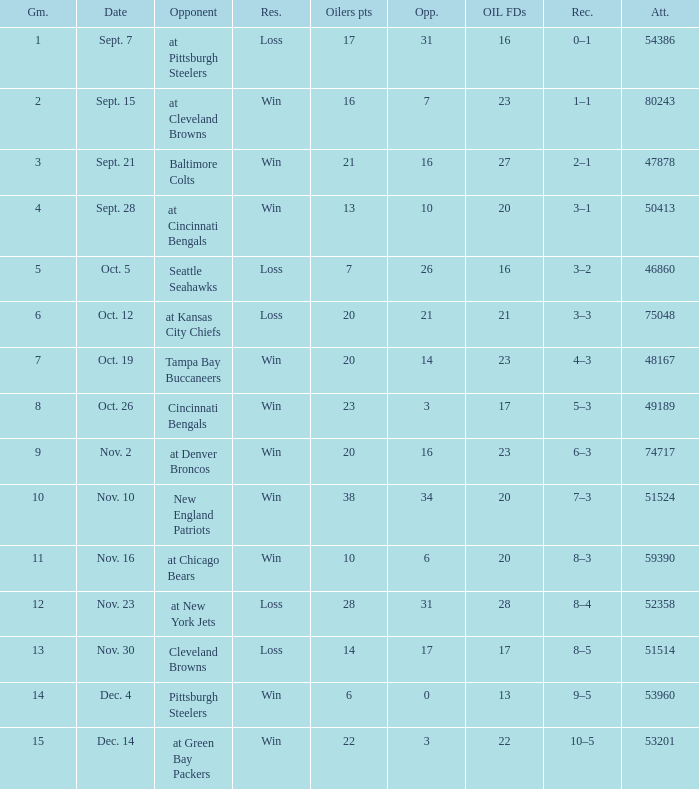What was the total opponents points for the game were the Oilers scored 21? 16.0. 